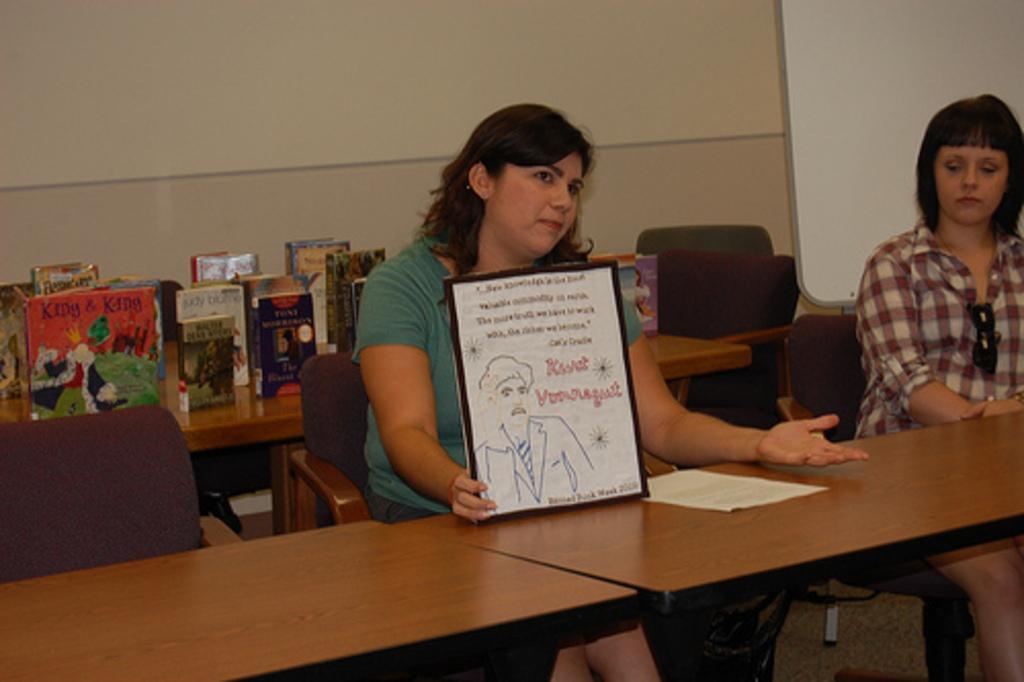Can you describe this image briefly? In the image we can see there are women who are sitting on chairs and a woman in the middle is holding a photo frame and at the back there are books kept on the table. 